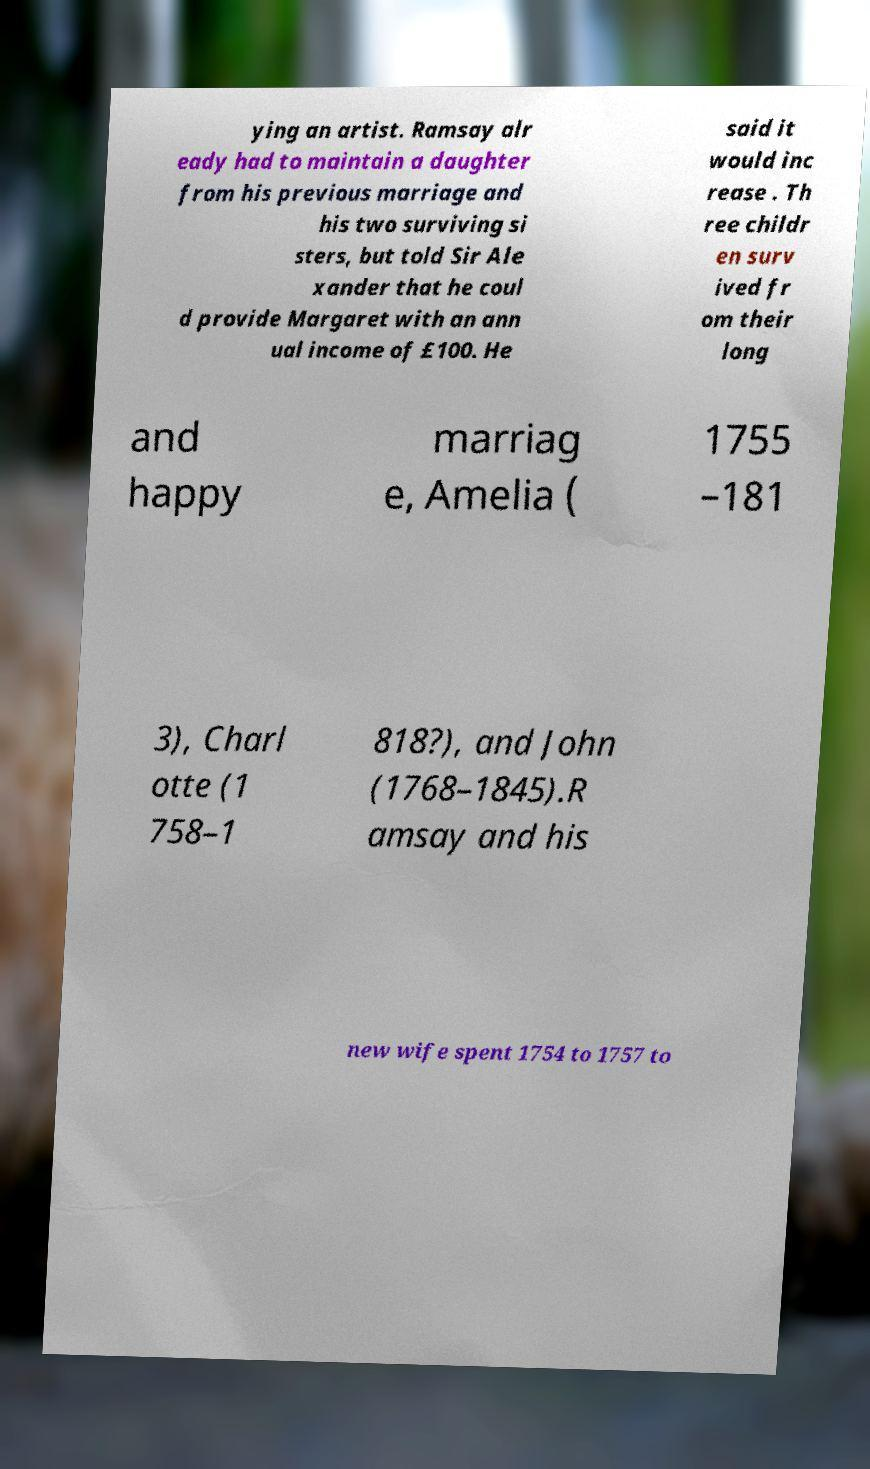Could you assist in decoding the text presented in this image and type it out clearly? ying an artist. Ramsay alr eady had to maintain a daughter from his previous marriage and his two surviving si sters, but told Sir Ale xander that he coul d provide Margaret with an ann ual income of £100. He said it would inc rease . Th ree childr en surv ived fr om their long and happy marriag e, Amelia ( 1755 –181 3), Charl otte (1 758–1 818?), and John (1768–1845).R amsay and his new wife spent 1754 to 1757 to 